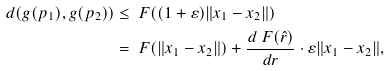<formula> <loc_0><loc_0><loc_500><loc_500>d ( g ( p _ { 1 } ) , g ( p _ { 2 } ) ) & \leq \ F ( ( 1 + \varepsilon ) \| x _ { 1 } - x _ { 2 } \| ) \\ & = \ F ( \| x _ { 1 } - x _ { 2 } \| ) + \frac { d \ F ( \hat { r } ) } { d r } \cdot \varepsilon \| x _ { 1 } - x _ { 2 } \| ,</formula> 